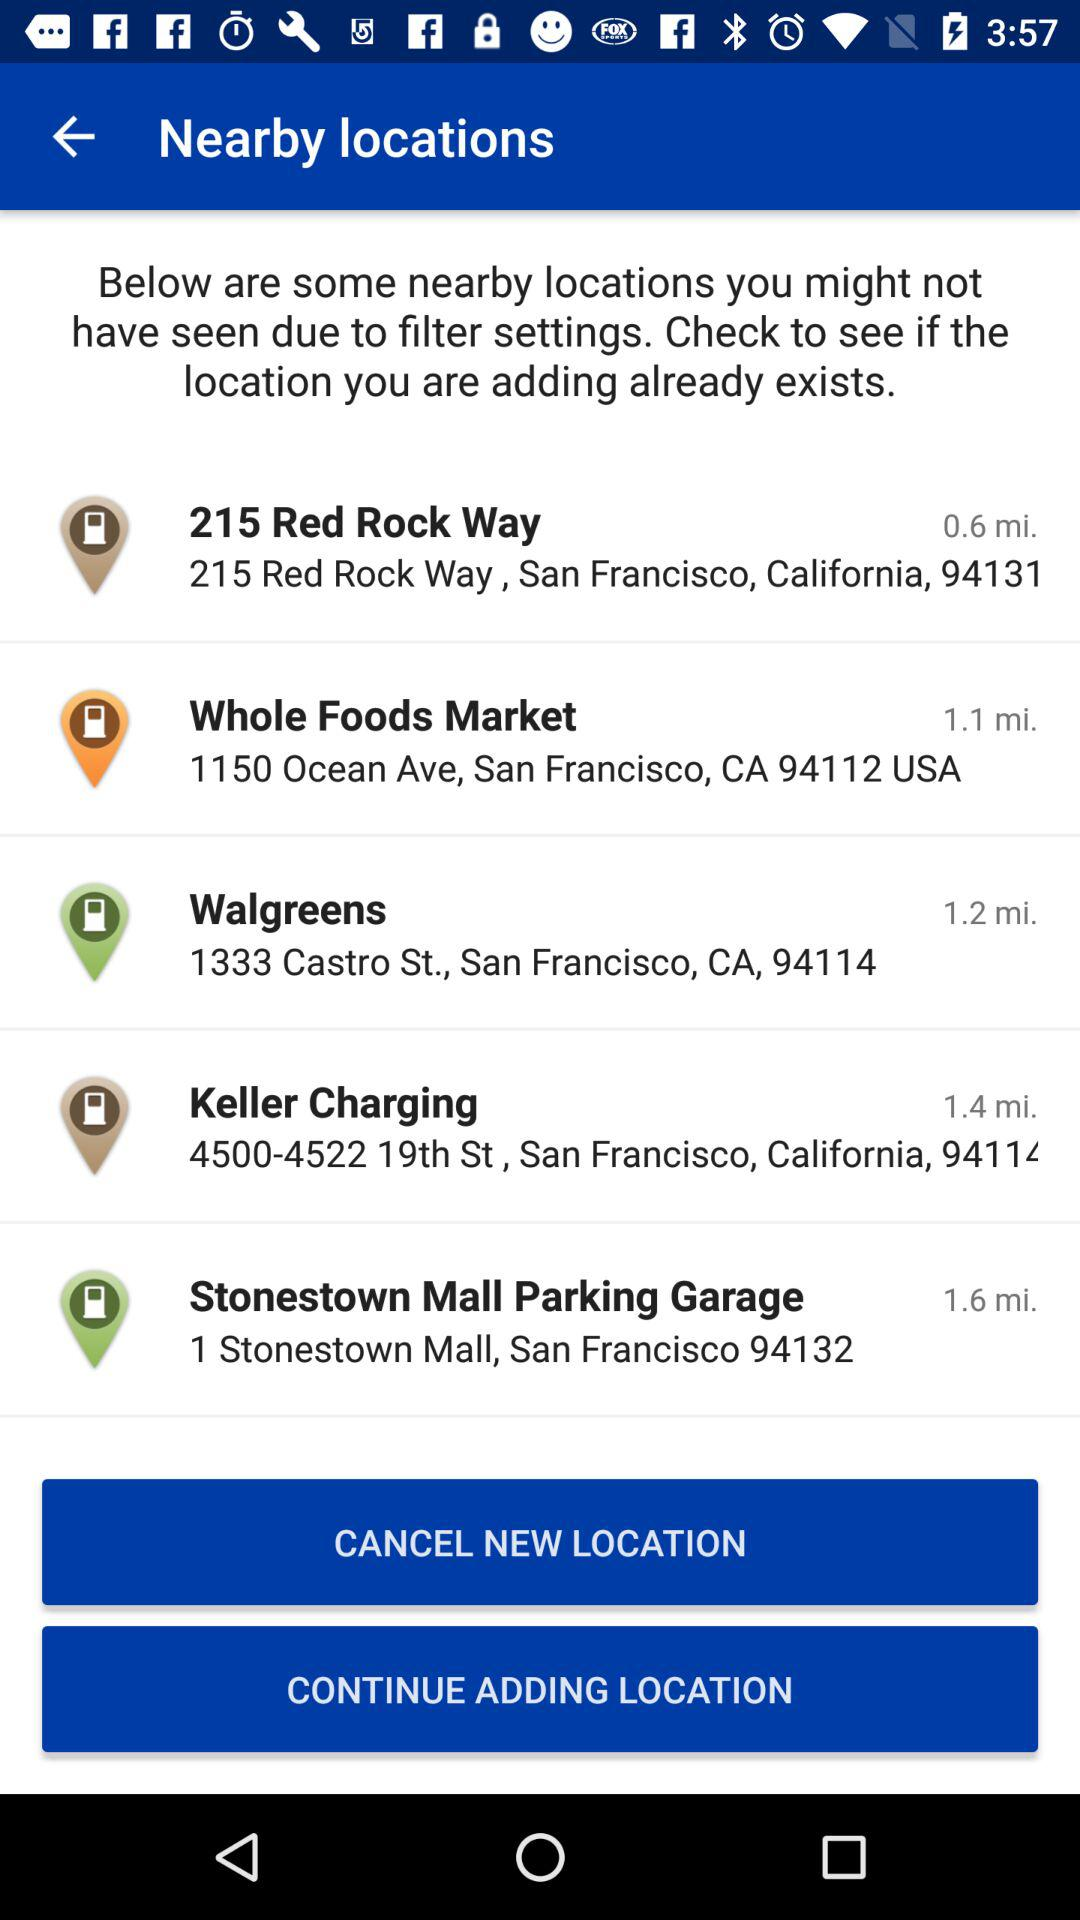What is the address of 215 Red Rock Way? The address is 215 Red Rock Way, San Francisco, California, 94131. 